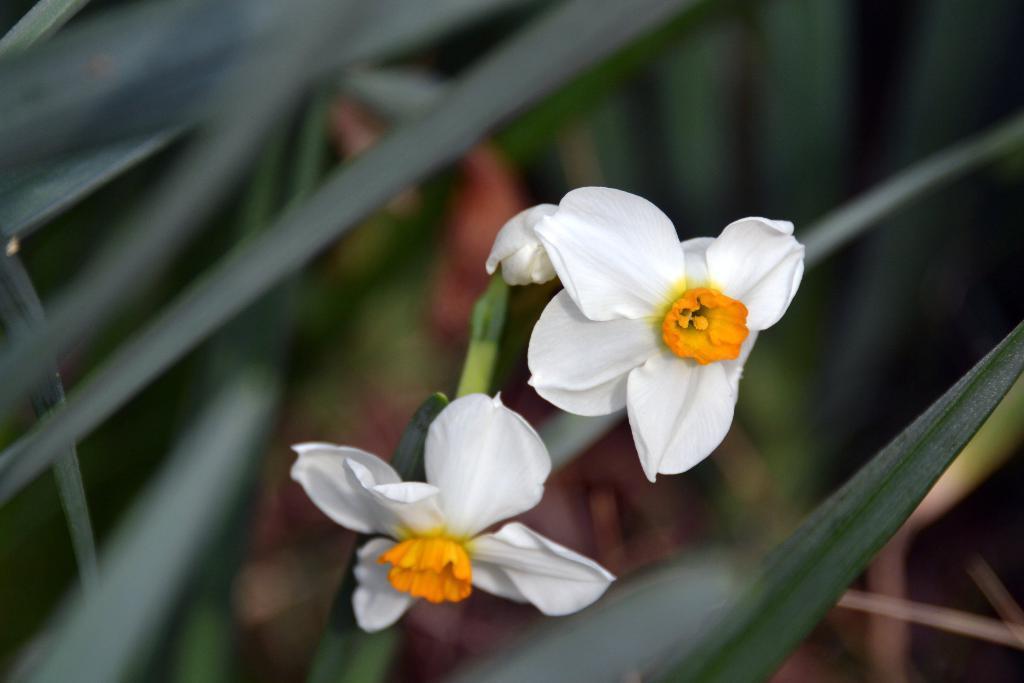In one or two sentences, can you explain what this image depicts? In this image there is a plant with two white color flowers, and there is blur background. 